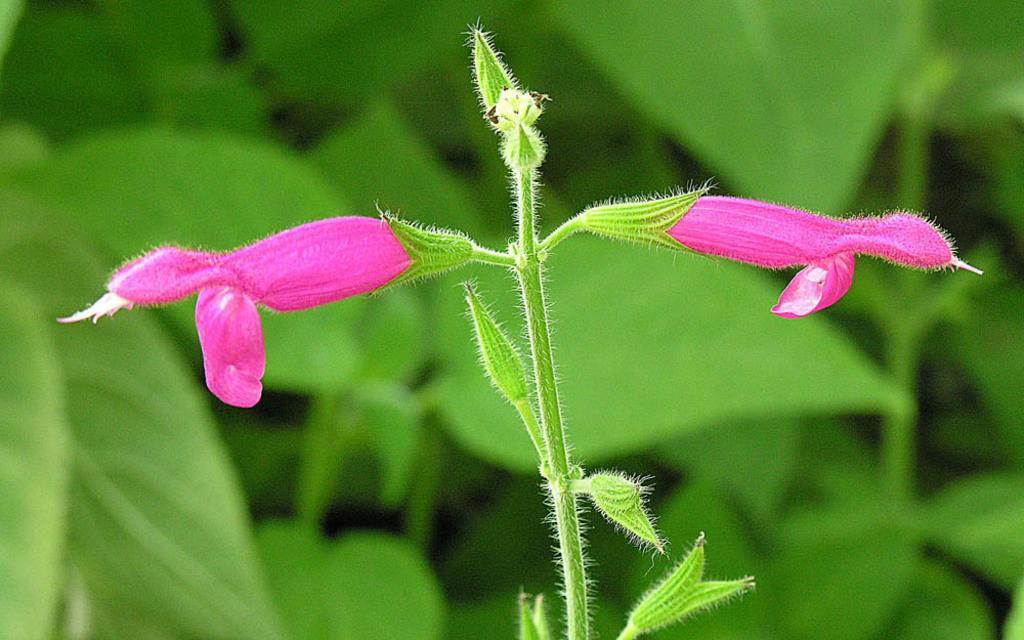Can you describe this image briefly? In the foreground of the picture there are flowers, buds and stem of a plant. In the background there is greenery. The background is blurred. 